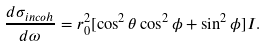<formula> <loc_0><loc_0><loc_500><loc_500>\frac { d \sigma _ { i n c o h } } { d \omega } = r _ { 0 } ^ { 2 } [ \cos ^ { 2 } \theta \cos ^ { 2 } \phi + \sin ^ { 2 } \phi ] I .</formula> 